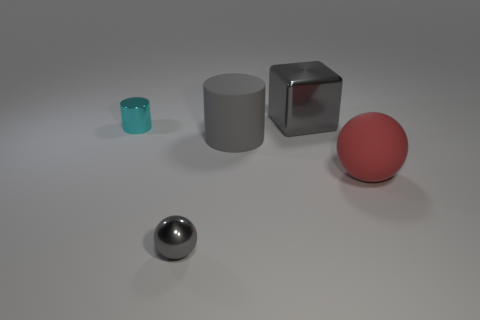Subtract all gray balls. How many balls are left? 1 Add 4 red spheres. How many objects exist? 9 Subtract all cylinders. How many objects are left? 3 Subtract 1 cylinders. How many cylinders are left? 1 Subtract all blue blocks. Subtract all cyan spheres. How many blocks are left? 1 Subtract all big red matte things. Subtract all red objects. How many objects are left? 3 Add 3 tiny gray balls. How many tiny gray balls are left? 4 Add 2 small purple metallic balls. How many small purple metallic balls exist? 2 Subtract 1 red spheres. How many objects are left? 4 